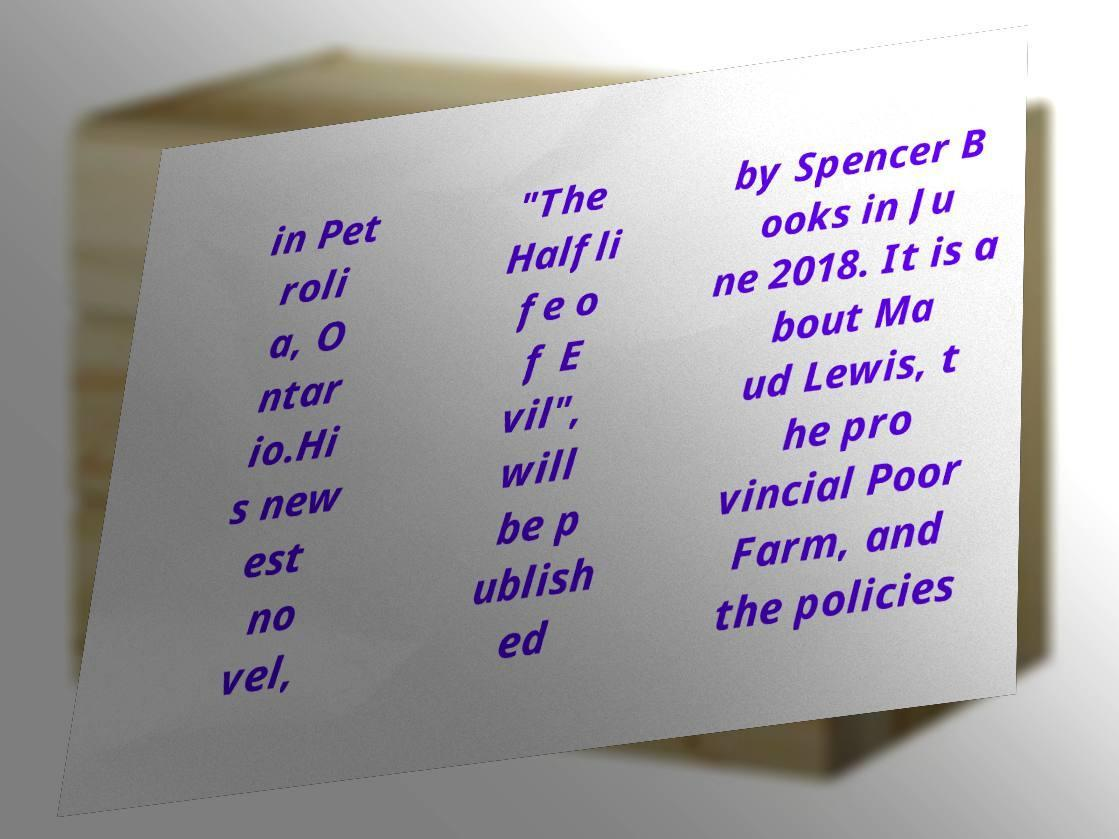Please read and relay the text visible in this image. What does it say? in Pet roli a, O ntar io.Hi s new est no vel, "The Halfli fe o f E vil", will be p ublish ed by Spencer B ooks in Ju ne 2018. It is a bout Ma ud Lewis, t he pro vincial Poor Farm, and the policies 